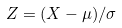Convert formula to latex. <formula><loc_0><loc_0><loc_500><loc_500>Z = ( X - \mu ) / \sigma</formula> 